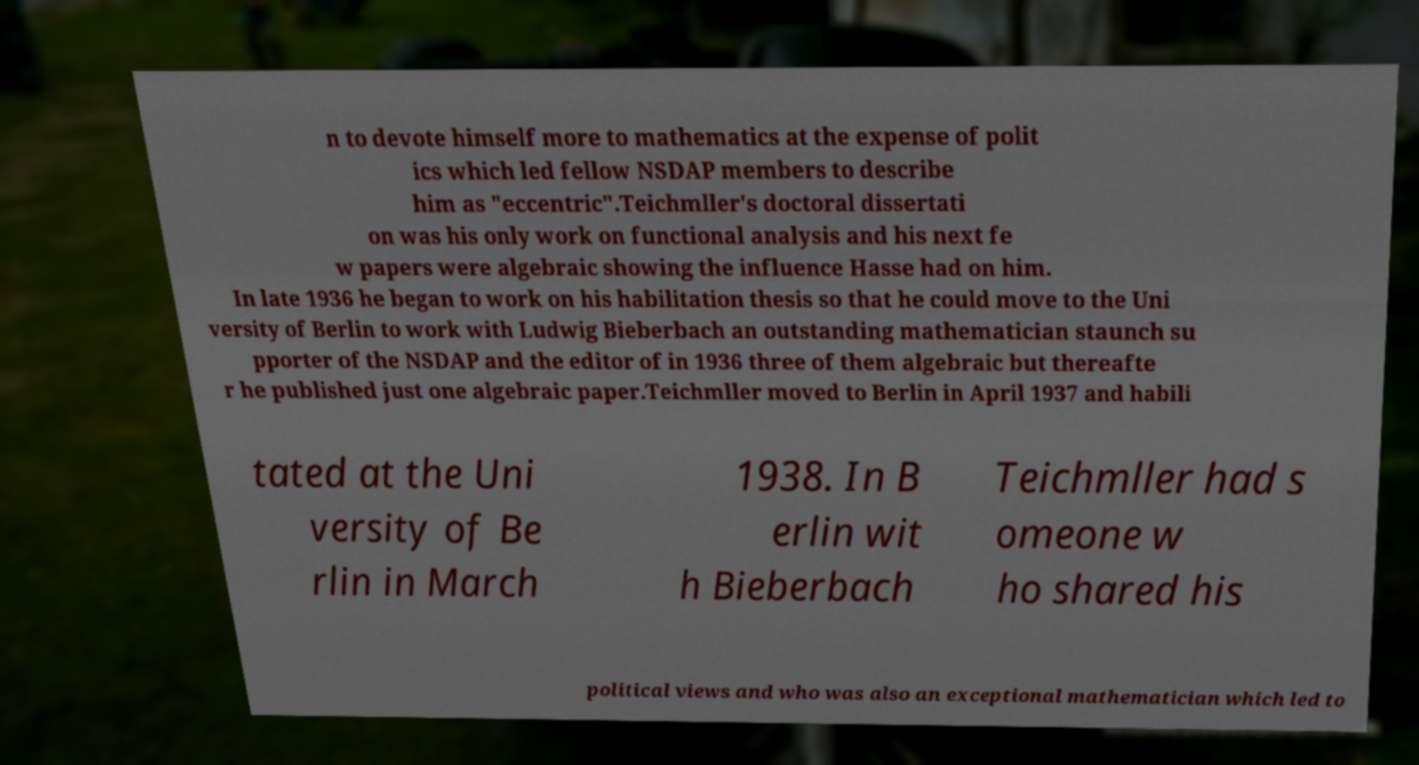Could you extract and type out the text from this image? n to devote himself more to mathematics at the expense of polit ics which led fellow NSDAP members to describe him as "eccentric".Teichmller's doctoral dissertati on was his only work on functional analysis and his next fe w papers were algebraic showing the influence Hasse had on him. In late 1936 he began to work on his habilitation thesis so that he could move to the Uni versity of Berlin to work with Ludwig Bieberbach an outstanding mathematician staunch su pporter of the NSDAP and the editor of in 1936 three of them algebraic but thereafte r he published just one algebraic paper.Teichmller moved to Berlin in April 1937 and habili tated at the Uni versity of Be rlin in March 1938. In B erlin wit h Bieberbach Teichmller had s omeone w ho shared his political views and who was also an exceptional mathematician which led to 